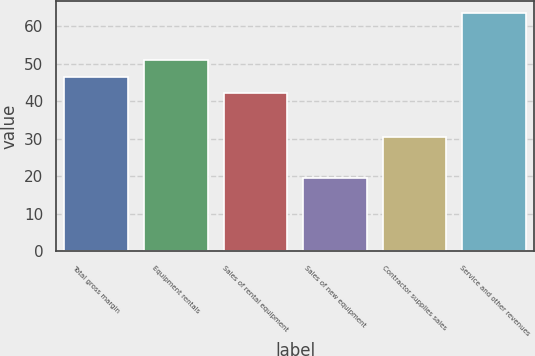<chart> <loc_0><loc_0><loc_500><loc_500><bar_chart><fcel>Total gross margin<fcel>Equipment rentals<fcel>Sales of rental equipment<fcel>Sales of new equipment<fcel>Contractor supplies sales<fcel>Service and other revenues<nl><fcel>46.51<fcel>50.92<fcel>42.1<fcel>19.5<fcel>30.6<fcel>63.6<nl></chart> 